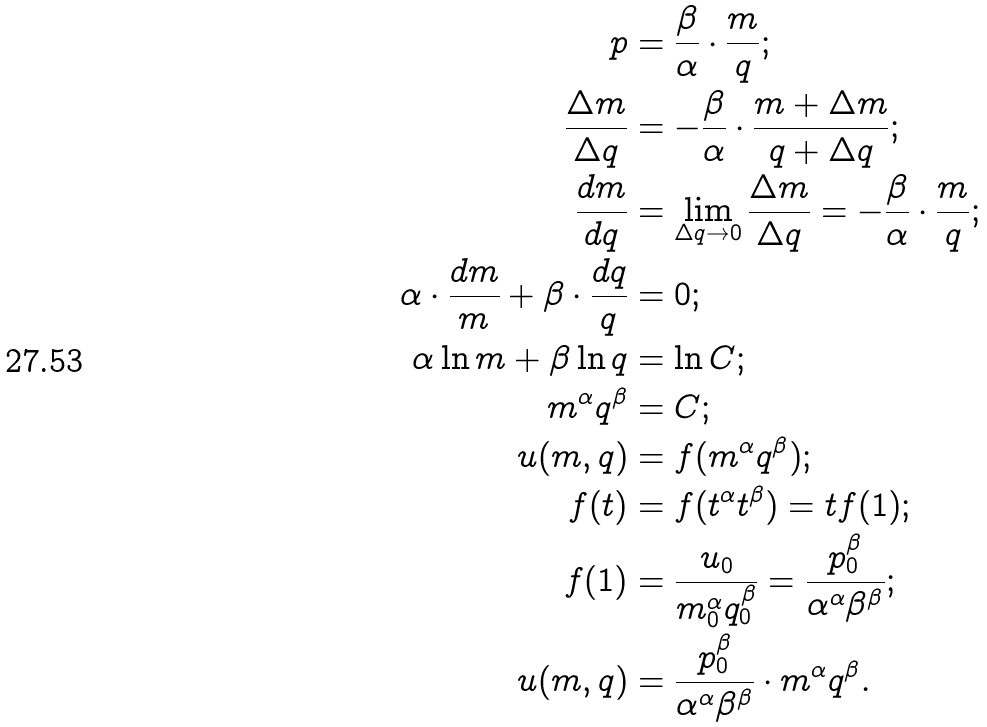<formula> <loc_0><loc_0><loc_500><loc_500>p & = \frac { \beta } { \alpha } \cdot \frac { m } { q } ; \\ \frac { \Delta m } { \Delta q } & = - \frac { \beta } { \alpha } \cdot \frac { m + \Delta m } { q + \Delta q } ; \\ \frac { d m } { d q } & = \lim _ { \Delta q \rightarrow 0 } \frac { \Delta m } { \Delta q } = - \frac { \beta } { \alpha } \cdot \frac { m } { q } ; \\ \alpha \cdot \frac { d m } { m } + \beta \cdot \frac { d q } { q } & = 0 ; \\ \alpha \ln m + \beta \ln q & = \ln C ; \\ m ^ { \alpha } q ^ { \beta } & = C ; \\ u ( m , q ) & = f ( m ^ { \alpha } q ^ { \beta } ) ; \\ f ( t ) & = f ( t ^ { \alpha } t ^ { \beta } ) = t f ( 1 ) ; \\ f ( 1 ) & = \frac { u _ { 0 } } { m _ { 0 } ^ { \alpha } q _ { 0 } ^ { \beta } } = \frac { p _ { 0 } ^ { \beta } } { \alpha ^ { \alpha } \beta ^ { \beta } } ; \\ u ( m , q ) & = \frac { p _ { 0 } ^ { \beta } } { \alpha ^ { \alpha } \beta ^ { \beta } } \cdot m ^ { \alpha } q ^ { \beta } .</formula> 